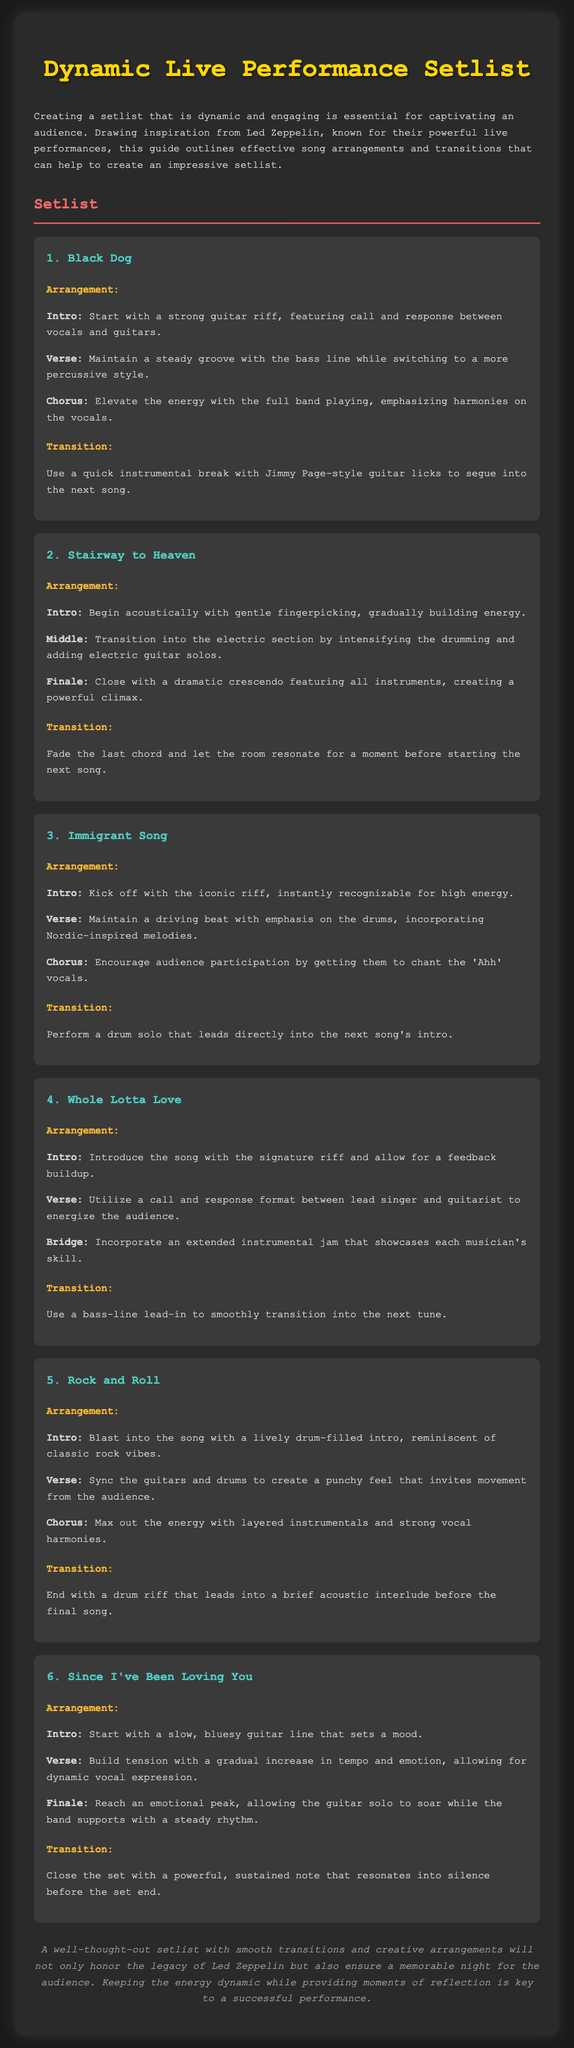What is the title of the document? The title is prominently displayed at the top of the document, indicating the focus on live performance setlists.
Answer: Dynamic Live Performance Setlist How many songs are in the setlist? The document lists six distinct songs in the setlist.
Answer: 6 What song starts with a gentle acoustic fingerpicking? The arrangement specifically mentions the transition from acoustic to electric for this song.
Answer: Stairway to Heaven What is used to transition from "Black Dog" to the next song? The transition between songs is marked by a unique instrumental element.
Answer: Quick instrumental break Which section follows the introduction in "Since I've Been Loving You"? The arrangement outlines the progression after the initial introduction of the song.
Answer: Verse What color is used for the song titles in the document? The styling for the song titles is indicated by the text color defined in the document's style section.
Answer: Light blue What musical element is encouraged during the chorus of "Immigrant Song"? The document mentions audience interaction as a part of the song arrangement.
Answer: Audience participation How does "Rock and Roll" begin? The introduction is described in the arrangement for the song, highlighting a specific musical feature.
Answer: Lively drum-filled intro 